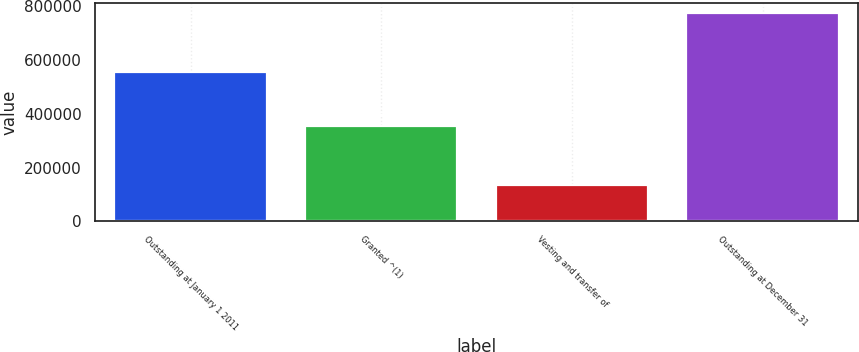<chart> <loc_0><loc_0><loc_500><loc_500><bar_chart><fcel>Outstanding at January 1 2011<fcel>Granted ^(1)<fcel>Vesting and transfer of<fcel>Outstanding at December 31<nl><fcel>556186<fcel>354660<fcel>136058<fcel>774788<nl></chart> 